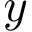Convert formula to latex. <formula><loc_0><loc_0><loc_500><loc_500>y</formula> 